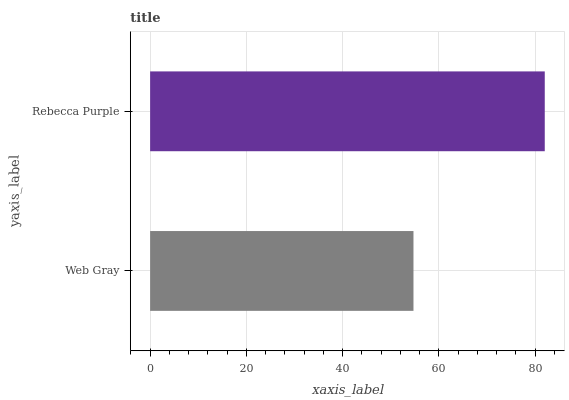Is Web Gray the minimum?
Answer yes or no. Yes. Is Rebecca Purple the maximum?
Answer yes or no. Yes. Is Rebecca Purple the minimum?
Answer yes or no. No. Is Rebecca Purple greater than Web Gray?
Answer yes or no. Yes. Is Web Gray less than Rebecca Purple?
Answer yes or no. Yes. Is Web Gray greater than Rebecca Purple?
Answer yes or no. No. Is Rebecca Purple less than Web Gray?
Answer yes or no. No. Is Rebecca Purple the high median?
Answer yes or no. Yes. Is Web Gray the low median?
Answer yes or no. Yes. Is Web Gray the high median?
Answer yes or no. No. Is Rebecca Purple the low median?
Answer yes or no. No. 